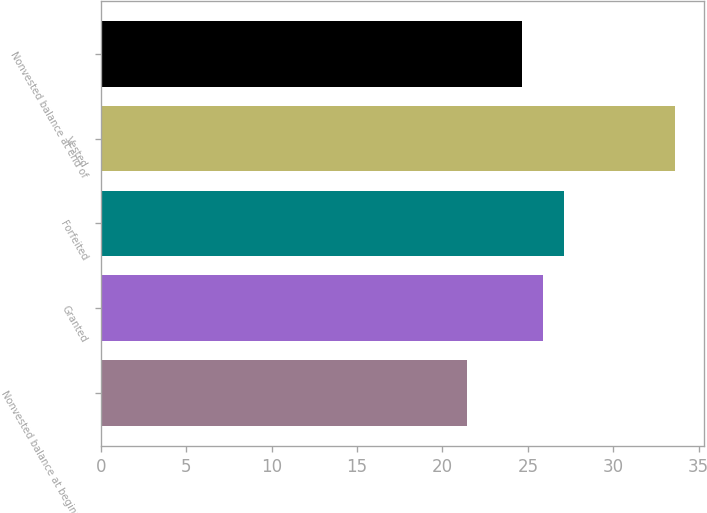Convert chart to OTSL. <chart><loc_0><loc_0><loc_500><loc_500><bar_chart><fcel>Nonvested balance at beginning<fcel>Granted<fcel>Forfeited<fcel>Vested<fcel>Nonvested balance at end of<nl><fcel>21.46<fcel>25.87<fcel>27.09<fcel>33.64<fcel>24.65<nl></chart> 